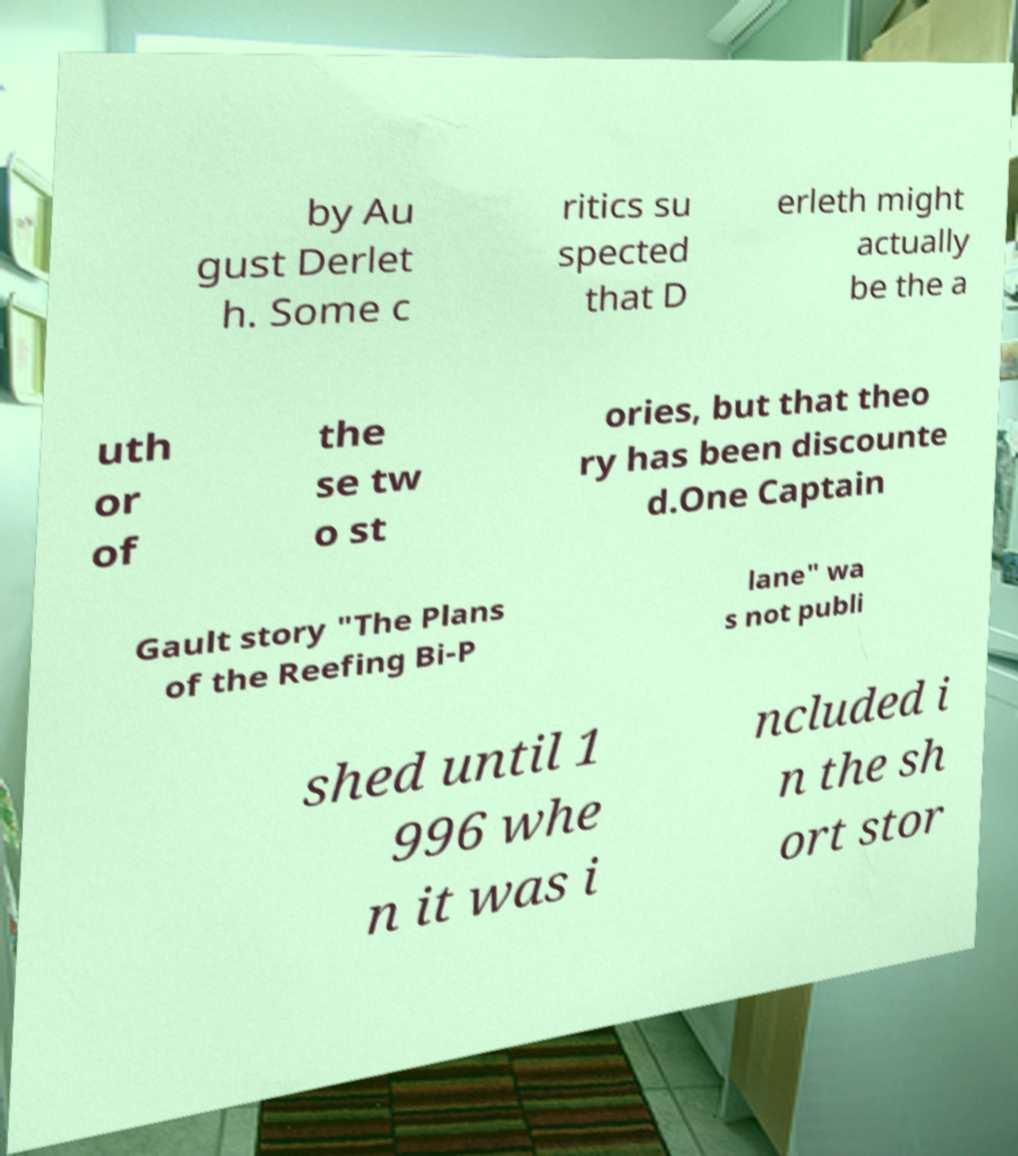Can you accurately transcribe the text from the provided image for me? by Au gust Derlet h. Some c ritics su spected that D erleth might actually be the a uth or of the se tw o st ories, but that theo ry has been discounte d.One Captain Gault story "The Plans of the Reefing Bi-P lane" wa s not publi shed until 1 996 whe n it was i ncluded i n the sh ort stor 